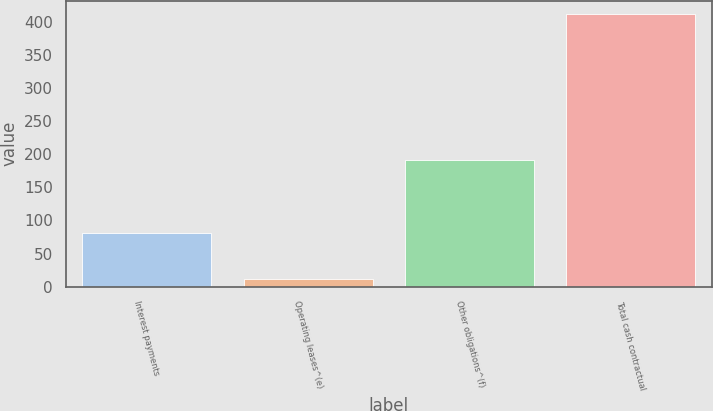<chart> <loc_0><loc_0><loc_500><loc_500><bar_chart><fcel>Interest payments<fcel>Operating leases^(e)<fcel>Other obligations^(f)<fcel>Total cash contractual<nl><fcel>81<fcel>11<fcel>191<fcel>411<nl></chart> 